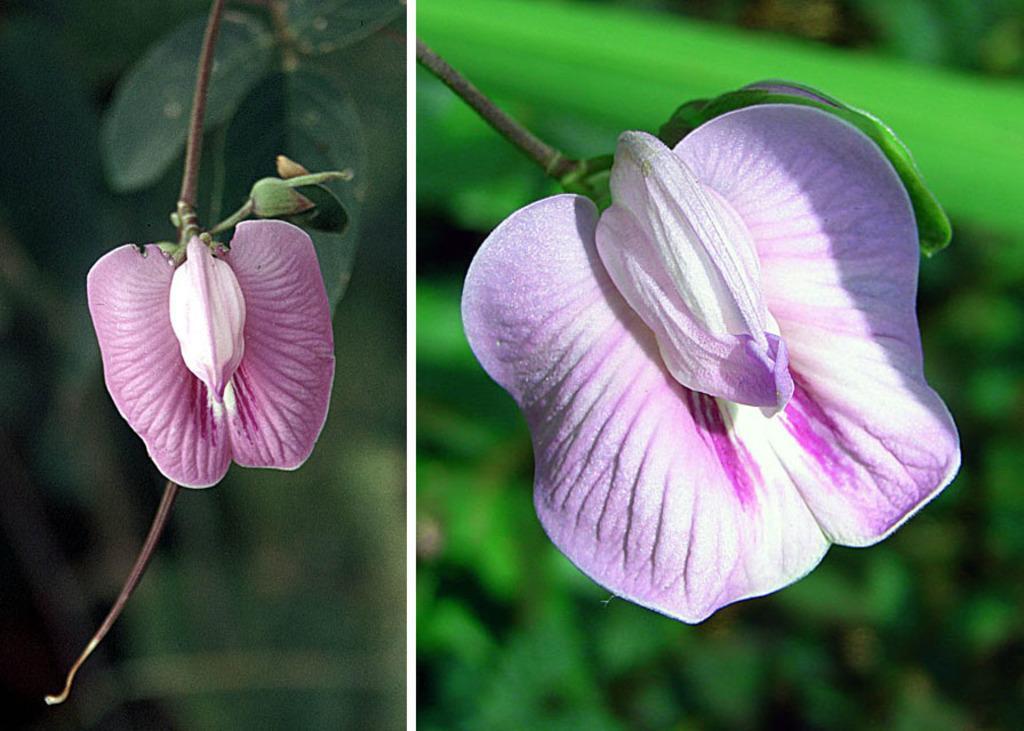Can you describe this image briefly? It is a collage picture. In the center of the image we can see flowers,which are in pink color. In the background we can see plants. 